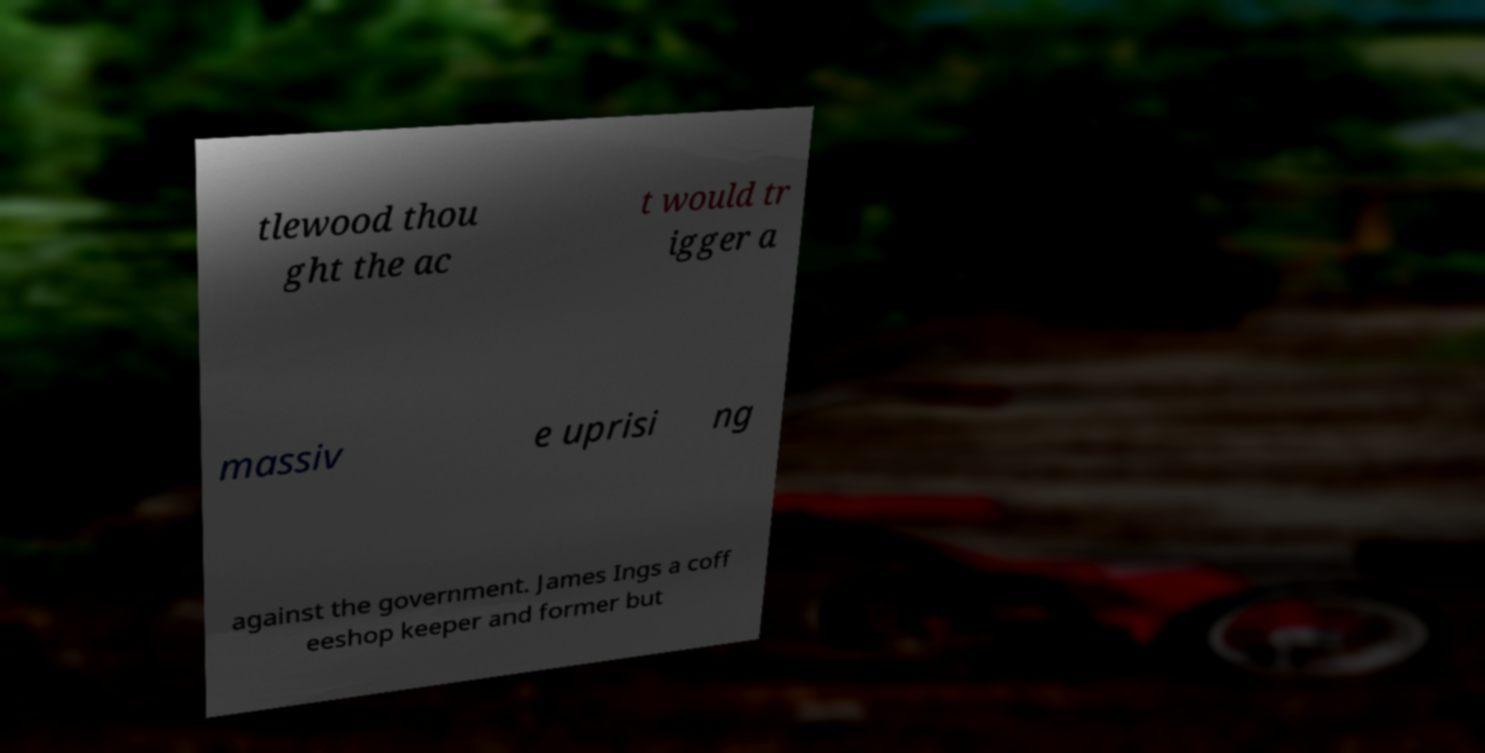Please identify and transcribe the text found in this image. tlewood thou ght the ac t would tr igger a massiv e uprisi ng against the government. James Ings a coff eeshop keeper and former but 